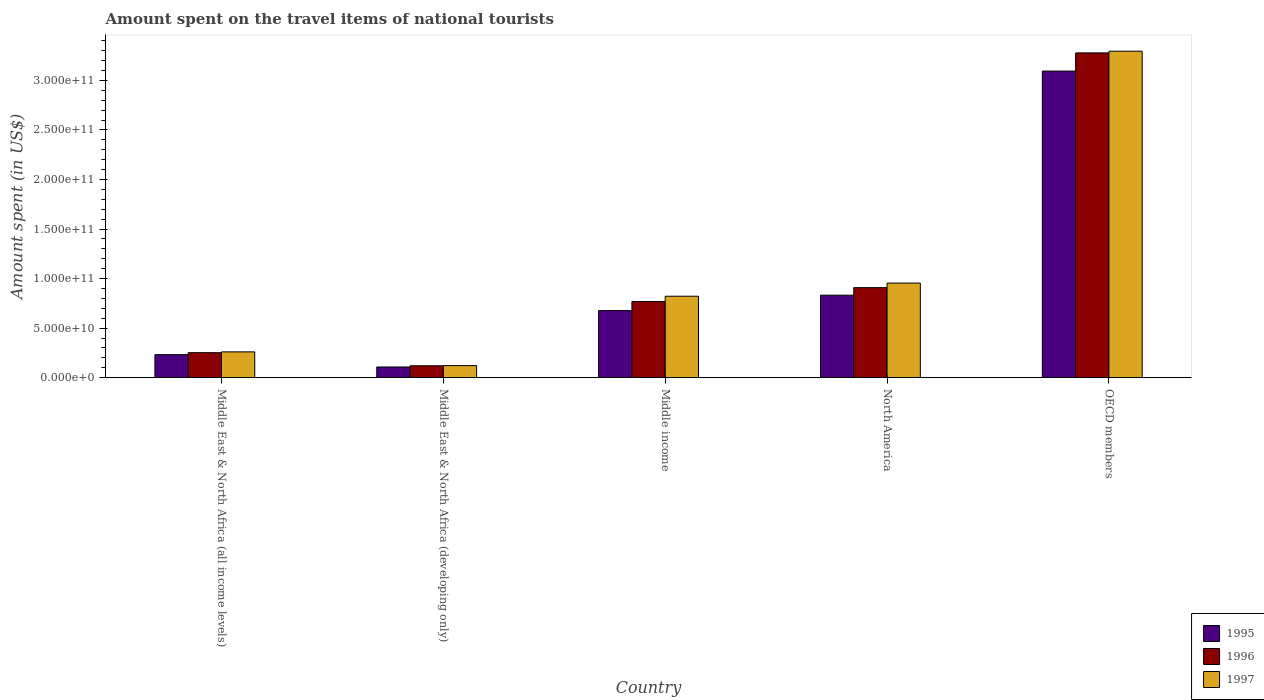Are the number of bars per tick equal to the number of legend labels?
Ensure brevity in your answer.  Yes. Are the number of bars on each tick of the X-axis equal?
Your response must be concise. Yes. How many bars are there on the 1st tick from the left?
Keep it short and to the point. 3. How many bars are there on the 4th tick from the right?
Provide a succinct answer. 3. What is the label of the 5th group of bars from the left?
Offer a very short reply. OECD members. In how many cases, is the number of bars for a given country not equal to the number of legend labels?
Provide a succinct answer. 0. What is the amount spent on the travel items of national tourists in 1996 in Middle East & North Africa (developing only)?
Ensure brevity in your answer.  1.20e+1. Across all countries, what is the maximum amount spent on the travel items of national tourists in 1997?
Provide a short and direct response. 3.29e+11. Across all countries, what is the minimum amount spent on the travel items of national tourists in 1995?
Your answer should be compact. 1.08e+1. In which country was the amount spent on the travel items of national tourists in 1996 minimum?
Ensure brevity in your answer.  Middle East & North Africa (developing only). What is the total amount spent on the travel items of national tourists in 1997 in the graph?
Provide a succinct answer. 5.45e+11. What is the difference between the amount spent on the travel items of national tourists in 1997 in Middle income and that in North America?
Your answer should be very brief. -1.33e+1. What is the difference between the amount spent on the travel items of national tourists in 1997 in Middle income and the amount spent on the travel items of national tourists in 1996 in North America?
Keep it short and to the point. -8.66e+09. What is the average amount spent on the travel items of national tourists in 1996 per country?
Give a very brief answer. 1.07e+11. What is the difference between the amount spent on the travel items of national tourists of/in 1997 and amount spent on the travel items of national tourists of/in 1995 in North America?
Offer a very short reply. 1.22e+1. What is the ratio of the amount spent on the travel items of national tourists in 1995 in Middle East & North Africa (developing only) to that in OECD members?
Your response must be concise. 0.03. Is the amount spent on the travel items of national tourists in 1996 in Middle East & North Africa (developing only) less than that in North America?
Your answer should be compact. Yes. What is the difference between the highest and the second highest amount spent on the travel items of national tourists in 1996?
Your answer should be compact. 2.51e+11. What is the difference between the highest and the lowest amount spent on the travel items of national tourists in 1996?
Your answer should be very brief. 3.16e+11. In how many countries, is the amount spent on the travel items of national tourists in 1996 greater than the average amount spent on the travel items of national tourists in 1996 taken over all countries?
Offer a terse response. 1. Is the sum of the amount spent on the travel items of national tourists in 1996 in Middle income and OECD members greater than the maximum amount spent on the travel items of national tourists in 1995 across all countries?
Your answer should be very brief. Yes. Are all the bars in the graph horizontal?
Your answer should be very brief. No. What is the difference between two consecutive major ticks on the Y-axis?
Provide a short and direct response. 5.00e+1. Are the values on the major ticks of Y-axis written in scientific E-notation?
Offer a very short reply. Yes. Does the graph contain any zero values?
Make the answer very short. No. Does the graph contain grids?
Make the answer very short. No. Where does the legend appear in the graph?
Ensure brevity in your answer.  Bottom right. What is the title of the graph?
Your answer should be very brief. Amount spent on the travel items of national tourists. Does "1976" appear as one of the legend labels in the graph?
Your response must be concise. No. What is the label or title of the Y-axis?
Provide a succinct answer. Amount spent (in US$). What is the Amount spent (in US$) in 1995 in Middle East & North Africa (all income levels)?
Keep it short and to the point. 2.32e+1. What is the Amount spent (in US$) of 1996 in Middle East & North Africa (all income levels)?
Offer a very short reply. 2.52e+1. What is the Amount spent (in US$) in 1997 in Middle East & North Africa (all income levels)?
Give a very brief answer. 2.60e+1. What is the Amount spent (in US$) of 1995 in Middle East & North Africa (developing only)?
Make the answer very short. 1.08e+1. What is the Amount spent (in US$) of 1996 in Middle East & North Africa (developing only)?
Keep it short and to the point. 1.20e+1. What is the Amount spent (in US$) of 1997 in Middle East & North Africa (developing only)?
Provide a short and direct response. 1.22e+1. What is the Amount spent (in US$) of 1995 in Middle income?
Give a very brief answer. 6.77e+1. What is the Amount spent (in US$) of 1996 in Middle income?
Make the answer very short. 7.69e+1. What is the Amount spent (in US$) of 1997 in Middle income?
Your answer should be very brief. 8.22e+1. What is the Amount spent (in US$) of 1995 in North America?
Make the answer very short. 8.32e+1. What is the Amount spent (in US$) in 1996 in North America?
Give a very brief answer. 9.09e+1. What is the Amount spent (in US$) in 1997 in North America?
Your answer should be very brief. 9.55e+1. What is the Amount spent (in US$) in 1995 in OECD members?
Offer a terse response. 3.09e+11. What is the Amount spent (in US$) in 1996 in OECD members?
Give a very brief answer. 3.28e+11. What is the Amount spent (in US$) in 1997 in OECD members?
Provide a succinct answer. 3.29e+11. Across all countries, what is the maximum Amount spent (in US$) of 1995?
Give a very brief answer. 3.09e+11. Across all countries, what is the maximum Amount spent (in US$) in 1996?
Ensure brevity in your answer.  3.28e+11. Across all countries, what is the maximum Amount spent (in US$) in 1997?
Provide a succinct answer. 3.29e+11. Across all countries, what is the minimum Amount spent (in US$) of 1995?
Provide a succinct answer. 1.08e+1. Across all countries, what is the minimum Amount spent (in US$) in 1996?
Your response must be concise. 1.20e+1. Across all countries, what is the minimum Amount spent (in US$) in 1997?
Keep it short and to the point. 1.22e+1. What is the total Amount spent (in US$) in 1995 in the graph?
Provide a succinct answer. 4.94e+11. What is the total Amount spent (in US$) of 1996 in the graph?
Offer a very short reply. 5.33e+11. What is the total Amount spent (in US$) in 1997 in the graph?
Your answer should be compact. 5.45e+11. What is the difference between the Amount spent (in US$) of 1995 in Middle East & North Africa (all income levels) and that in Middle East & North Africa (developing only)?
Your response must be concise. 1.25e+1. What is the difference between the Amount spent (in US$) in 1996 in Middle East & North Africa (all income levels) and that in Middle East & North Africa (developing only)?
Your response must be concise. 1.32e+1. What is the difference between the Amount spent (in US$) in 1997 in Middle East & North Africa (all income levels) and that in Middle East & North Africa (developing only)?
Offer a terse response. 1.38e+1. What is the difference between the Amount spent (in US$) in 1995 in Middle East & North Africa (all income levels) and that in Middle income?
Keep it short and to the point. -4.45e+1. What is the difference between the Amount spent (in US$) of 1996 in Middle East & North Africa (all income levels) and that in Middle income?
Offer a terse response. -5.17e+1. What is the difference between the Amount spent (in US$) of 1997 in Middle East & North Africa (all income levels) and that in Middle income?
Ensure brevity in your answer.  -5.62e+1. What is the difference between the Amount spent (in US$) in 1995 in Middle East & North Africa (all income levels) and that in North America?
Provide a short and direct response. -6.00e+1. What is the difference between the Amount spent (in US$) of 1996 in Middle East & North Africa (all income levels) and that in North America?
Keep it short and to the point. -6.56e+1. What is the difference between the Amount spent (in US$) in 1997 in Middle East & North Africa (all income levels) and that in North America?
Offer a terse response. -6.95e+1. What is the difference between the Amount spent (in US$) of 1995 in Middle East & North Africa (all income levels) and that in OECD members?
Keep it short and to the point. -2.86e+11. What is the difference between the Amount spent (in US$) of 1996 in Middle East & North Africa (all income levels) and that in OECD members?
Your answer should be compact. -3.03e+11. What is the difference between the Amount spent (in US$) in 1997 in Middle East & North Africa (all income levels) and that in OECD members?
Provide a succinct answer. -3.03e+11. What is the difference between the Amount spent (in US$) in 1995 in Middle East & North Africa (developing only) and that in Middle income?
Offer a terse response. -5.69e+1. What is the difference between the Amount spent (in US$) of 1996 in Middle East & North Africa (developing only) and that in Middle income?
Make the answer very short. -6.49e+1. What is the difference between the Amount spent (in US$) of 1997 in Middle East & North Africa (developing only) and that in Middle income?
Your answer should be very brief. -7.00e+1. What is the difference between the Amount spent (in US$) in 1995 in Middle East & North Africa (developing only) and that in North America?
Provide a short and direct response. -7.25e+1. What is the difference between the Amount spent (in US$) in 1996 in Middle East & North Africa (developing only) and that in North America?
Offer a terse response. -7.88e+1. What is the difference between the Amount spent (in US$) of 1997 in Middle East & North Africa (developing only) and that in North America?
Provide a succinct answer. -8.33e+1. What is the difference between the Amount spent (in US$) of 1995 in Middle East & North Africa (developing only) and that in OECD members?
Keep it short and to the point. -2.99e+11. What is the difference between the Amount spent (in US$) of 1996 in Middle East & North Africa (developing only) and that in OECD members?
Offer a terse response. -3.16e+11. What is the difference between the Amount spent (in US$) of 1997 in Middle East & North Africa (developing only) and that in OECD members?
Your answer should be very brief. -3.17e+11. What is the difference between the Amount spent (in US$) in 1995 in Middle income and that in North America?
Offer a terse response. -1.55e+1. What is the difference between the Amount spent (in US$) of 1996 in Middle income and that in North America?
Your answer should be very brief. -1.39e+1. What is the difference between the Amount spent (in US$) in 1997 in Middle income and that in North America?
Make the answer very short. -1.33e+1. What is the difference between the Amount spent (in US$) of 1995 in Middle income and that in OECD members?
Offer a terse response. -2.42e+11. What is the difference between the Amount spent (in US$) in 1996 in Middle income and that in OECD members?
Your response must be concise. -2.51e+11. What is the difference between the Amount spent (in US$) of 1997 in Middle income and that in OECD members?
Your response must be concise. -2.47e+11. What is the difference between the Amount spent (in US$) of 1995 in North America and that in OECD members?
Offer a terse response. -2.26e+11. What is the difference between the Amount spent (in US$) in 1996 in North America and that in OECD members?
Your answer should be compact. -2.37e+11. What is the difference between the Amount spent (in US$) of 1997 in North America and that in OECD members?
Offer a terse response. -2.34e+11. What is the difference between the Amount spent (in US$) in 1995 in Middle East & North Africa (all income levels) and the Amount spent (in US$) in 1996 in Middle East & North Africa (developing only)?
Offer a terse response. 1.12e+1. What is the difference between the Amount spent (in US$) in 1995 in Middle East & North Africa (all income levels) and the Amount spent (in US$) in 1997 in Middle East & North Africa (developing only)?
Keep it short and to the point. 1.11e+1. What is the difference between the Amount spent (in US$) of 1996 in Middle East & North Africa (all income levels) and the Amount spent (in US$) of 1997 in Middle East & North Africa (developing only)?
Give a very brief answer. 1.30e+1. What is the difference between the Amount spent (in US$) of 1995 in Middle East & North Africa (all income levels) and the Amount spent (in US$) of 1996 in Middle income?
Offer a very short reply. -5.37e+1. What is the difference between the Amount spent (in US$) of 1995 in Middle East & North Africa (all income levels) and the Amount spent (in US$) of 1997 in Middle income?
Your response must be concise. -5.90e+1. What is the difference between the Amount spent (in US$) in 1996 in Middle East & North Africa (all income levels) and the Amount spent (in US$) in 1997 in Middle income?
Your answer should be very brief. -5.70e+1. What is the difference between the Amount spent (in US$) of 1995 in Middle East & North Africa (all income levels) and the Amount spent (in US$) of 1996 in North America?
Keep it short and to the point. -6.76e+1. What is the difference between the Amount spent (in US$) in 1995 in Middle East & North Africa (all income levels) and the Amount spent (in US$) in 1997 in North America?
Offer a terse response. -7.22e+1. What is the difference between the Amount spent (in US$) in 1996 in Middle East & North Africa (all income levels) and the Amount spent (in US$) in 1997 in North America?
Ensure brevity in your answer.  -7.03e+1. What is the difference between the Amount spent (in US$) of 1995 in Middle East & North Africa (all income levels) and the Amount spent (in US$) of 1996 in OECD members?
Your answer should be compact. -3.05e+11. What is the difference between the Amount spent (in US$) of 1995 in Middle East & North Africa (all income levels) and the Amount spent (in US$) of 1997 in OECD members?
Make the answer very short. -3.06e+11. What is the difference between the Amount spent (in US$) of 1996 in Middle East & North Africa (all income levels) and the Amount spent (in US$) of 1997 in OECD members?
Keep it short and to the point. -3.04e+11. What is the difference between the Amount spent (in US$) of 1995 in Middle East & North Africa (developing only) and the Amount spent (in US$) of 1996 in Middle income?
Make the answer very short. -6.61e+1. What is the difference between the Amount spent (in US$) in 1995 in Middle East & North Africa (developing only) and the Amount spent (in US$) in 1997 in Middle income?
Your response must be concise. -7.14e+1. What is the difference between the Amount spent (in US$) in 1996 in Middle East & North Africa (developing only) and the Amount spent (in US$) in 1997 in Middle income?
Your answer should be compact. -7.02e+1. What is the difference between the Amount spent (in US$) in 1995 in Middle East & North Africa (developing only) and the Amount spent (in US$) in 1996 in North America?
Your response must be concise. -8.01e+1. What is the difference between the Amount spent (in US$) of 1995 in Middle East & North Africa (developing only) and the Amount spent (in US$) of 1997 in North America?
Your answer should be compact. -8.47e+1. What is the difference between the Amount spent (in US$) in 1996 in Middle East & North Africa (developing only) and the Amount spent (in US$) in 1997 in North America?
Provide a succinct answer. -8.35e+1. What is the difference between the Amount spent (in US$) of 1995 in Middle East & North Africa (developing only) and the Amount spent (in US$) of 1996 in OECD members?
Offer a terse response. -3.17e+11. What is the difference between the Amount spent (in US$) of 1995 in Middle East & North Africa (developing only) and the Amount spent (in US$) of 1997 in OECD members?
Your answer should be compact. -3.19e+11. What is the difference between the Amount spent (in US$) of 1996 in Middle East & North Africa (developing only) and the Amount spent (in US$) of 1997 in OECD members?
Make the answer very short. -3.17e+11. What is the difference between the Amount spent (in US$) of 1995 in Middle income and the Amount spent (in US$) of 1996 in North America?
Give a very brief answer. -2.31e+1. What is the difference between the Amount spent (in US$) in 1995 in Middle income and the Amount spent (in US$) in 1997 in North America?
Offer a very short reply. -2.78e+1. What is the difference between the Amount spent (in US$) of 1996 in Middle income and the Amount spent (in US$) of 1997 in North America?
Ensure brevity in your answer.  -1.86e+1. What is the difference between the Amount spent (in US$) in 1995 in Middle income and the Amount spent (in US$) in 1996 in OECD members?
Offer a terse response. -2.60e+11. What is the difference between the Amount spent (in US$) of 1995 in Middle income and the Amount spent (in US$) of 1997 in OECD members?
Offer a terse response. -2.62e+11. What is the difference between the Amount spent (in US$) of 1996 in Middle income and the Amount spent (in US$) of 1997 in OECD members?
Your answer should be very brief. -2.53e+11. What is the difference between the Amount spent (in US$) in 1995 in North America and the Amount spent (in US$) in 1996 in OECD members?
Provide a short and direct response. -2.45e+11. What is the difference between the Amount spent (in US$) of 1995 in North America and the Amount spent (in US$) of 1997 in OECD members?
Provide a short and direct response. -2.46e+11. What is the difference between the Amount spent (in US$) of 1996 in North America and the Amount spent (in US$) of 1997 in OECD members?
Give a very brief answer. -2.39e+11. What is the average Amount spent (in US$) of 1995 per country?
Keep it short and to the point. 9.89e+1. What is the average Amount spent (in US$) in 1996 per country?
Your answer should be very brief. 1.07e+11. What is the average Amount spent (in US$) of 1997 per country?
Give a very brief answer. 1.09e+11. What is the difference between the Amount spent (in US$) of 1995 and Amount spent (in US$) of 1996 in Middle East & North Africa (all income levels)?
Make the answer very short. -1.99e+09. What is the difference between the Amount spent (in US$) of 1995 and Amount spent (in US$) of 1997 in Middle East & North Africa (all income levels)?
Your answer should be compact. -2.79e+09. What is the difference between the Amount spent (in US$) in 1996 and Amount spent (in US$) in 1997 in Middle East & North Africa (all income levels)?
Provide a succinct answer. -7.97e+08. What is the difference between the Amount spent (in US$) of 1995 and Amount spent (in US$) of 1996 in Middle East & North Africa (developing only)?
Make the answer very short. -1.24e+09. What is the difference between the Amount spent (in US$) in 1995 and Amount spent (in US$) in 1997 in Middle East & North Africa (developing only)?
Keep it short and to the point. -1.40e+09. What is the difference between the Amount spent (in US$) in 1996 and Amount spent (in US$) in 1997 in Middle East & North Africa (developing only)?
Provide a succinct answer. -1.61e+08. What is the difference between the Amount spent (in US$) in 1995 and Amount spent (in US$) in 1996 in Middle income?
Offer a very short reply. -9.19e+09. What is the difference between the Amount spent (in US$) of 1995 and Amount spent (in US$) of 1997 in Middle income?
Your response must be concise. -1.45e+1. What is the difference between the Amount spent (in US$) in 1996 and Amount spent (in US$) in 1997 in Middle income?
Your answer should be very brief. -5.28e+09. What is the difference between the Amount spent (in US$) of 1995 and Amount spent (in US$) of 1996 in North America?
Provide a short and direct response. -7.61e+09. What is the difference between the Amount spent (in US$) in 1995 and Amount spent (in US$) in 1997 in North America?
Your answer should be very brief. -1.22e+1. What is the difference between the Amount spent (in US$) in 1996 and Amount spent (in US$) in 1997 in North America?
Provide a short and direct response. -4.62e+09. What is the difference between the Amount spent (in US$) of 1995 and Amount spent (in US$) of 1996 in OECD members?
Keep it short and to the point. -1.83e+1. What is the difference between the Amount spent (in US$) of 1995 and Amount spent (in US$) of 1997 in OECD members?
Provide a succinct answer. -2.01e+1. What is the difference between the Amount spent (in US$) in 1996 and Amount spent (in US$) in 1997 in OECD members?
Keep it short and to the point. -1.72e+09. What is the ratio of the Amount spent (in US$) of 1995 in Middle East & North Africa (all income levels) to that in Middle East & North Africa (developing only)?
Give a very brief answer. 2.16. What is the ratio of the Amount spent (in US$) in 1996 in Middle East & North Africa (all income levels) to that in Middle East & North Africa (developing only)?
Your response must be concise. 2.1. What is the ratio of the Amount spent (in US$) in 1997 in Middle East & North Africa (all income levels) to that in Middle East & North Africa (developing only)?
Provide a short and direct response. 2.14. What is the ratio of the Amount spent (in US$) in 1995 in Middle East & North Africa (all income levels) to that in Middle income?
Keep it short and to the point. 0.34. What is the ratio of the Amount spent (in US$) of 1996 in Middle East & North Africa (all income levels) to that in Middle income?
Offer a terse response. 0.33. What is the ratio of the Amount spent (in US$) in 1997 in Middle East & North Africa (all income levels) to that in Middle income?
Provide a short and direct response. 0.32. What is the ratio of the Amount spent (in US$) of 1995 in Middle East & North Africa (all income levels) to that in North America?
Ensure brevity in your answer.  0.28. What is the ratio of the Amount spent (in US$) in 1996 in Middle East & North Africa (all income levels) to that in North America?
Ensure brevity in your answer.  0.28. What is the ratio of the Amount spent (in US$) in 1997 in Middle East & North Africa (all income levels) to that in North America?
Offer a very short reply. 0.27. What is the ratio of the Amount spent (in US$) of 1995 in Middle East & North Africa (all income levels) to that in OECD members?
Offer a very short reply. 0.08. What is the ratio of the Amount spent (in US$) of 1996 in Middle East & North Africa (all income levels) to that in OECD members?
Your response must be concise. 0.08. What is the ratio of the Amount spent (in US$) in 1997 in Middle East & North Africa (all income levels) to that in OECD members?
Provide a succinct answer. 0.08. What is the ratio of the Amount spent (in US$) in 1995 in Middle East & North Africa (developing only) to that in Middle income?
Give a very brief answer. 0.16. What is the ratio of the Amount spent (in US$) of 1996 in Middle East & North Africa (developing only) to that in Middle income?
Provide a succinct answer. 0.16. What is the ratio of the Amount spent (in US$) of 1997 in Middle East & North Africa (developing only) to that in Middle income?
Offer a terse response. 0.15. What is the ratio of the Amount spent (in US$) in 1995 in Middle East & North Africa (developing only) to that in North America?
Your answer should be very brief. 0.13. What is the ratio of the Amount spent (in US$) in 1996 in Middle East & North Africa (developing only) to that in North America?
Ensure brevity in your answer.  0.13. What is the ratio of the Amount spent (in US$) in 1997 in Middle East & North Africa (developing only) to that in North America?
Your answer should be compact. 0.13. What is the ratio of the Amount spent (in US$) in 1995 in Middle East & North Africa (developing only) to that in OECD members?
Offer a very short reply. 0.03. What is the ratio of the Amount spent (in US$) in 1996 in Middle East & North Africa (developing only) to that in OECD members?
Give a very brief answer. 0.04. What is the ratio of the Amount spent (in US$) in 1997 in Middle East & North Africa (developing only) to that in OECD members?
Give a very brief answer. 0.04. What is the ratio of the Amount spent (in US$) in 1995 in Middle income to that in North America?
Offer a terse response. 0.81. What is the ratio of the Amount spent (in US$) of 1996 in Middle income to that in North America?
Offer a very short reply. 0.85. What is the ratio of the Amount spent (in US$) in 1997 in Middle income to that in North America?
Your answer should be very brief. 0.86. What is the ratio of the Amount spent (in US$) of 1995 in Middle income to that in OECD members?
Provide a succinct answer. 0.22. What is the ratio of the Amount spent (in US$) of 1996 in Middle income to that in OECD members?
Make the answer very short. 0.23. What is the ratio of the Amount spent (in US$) in 1997 in Middle income to that in OECD members?
Make the answer very short. 0.25. What is the ratio of the Amount spent (in US$) in 1995 in North America to that in OECD members?
Make the answer very short. 0.27. What is the ratio of the Amount spent (in US$) of 1996 in North America to that in OECD members?
Give a very brief answer. 0.28. What is the ratio of the Amount spent (in US$) in 1997 in North America to that in OECD members?
Your answer should be very brief. 0.29. What is the difference between the highest and the second highest Amount spent (in US$) of 1995?
Provide a short and direct response. 2.26e+11. What is the difference between the highest and the second highest Amount spent (in US$) in 1996?
Offer a very short reply. 2.37e+11. What is the difference between the highest and the second highest Amount spent (in US$) in 1997?
Your response must be concise. 2.34e+11. What is the difference between the highest and the lowest Amount spent (in US$) of 1995?
Your answer should be very brief. 2.99e+11. What is the difference between the highest and the lowest Amount spent (in US$) of 1996?
Offer a terse response. 3.16e+11. What is the difference between the highest and the lowest Amount spent (in US$) in 1997?
Your response must be concise. 3.17e+11. 